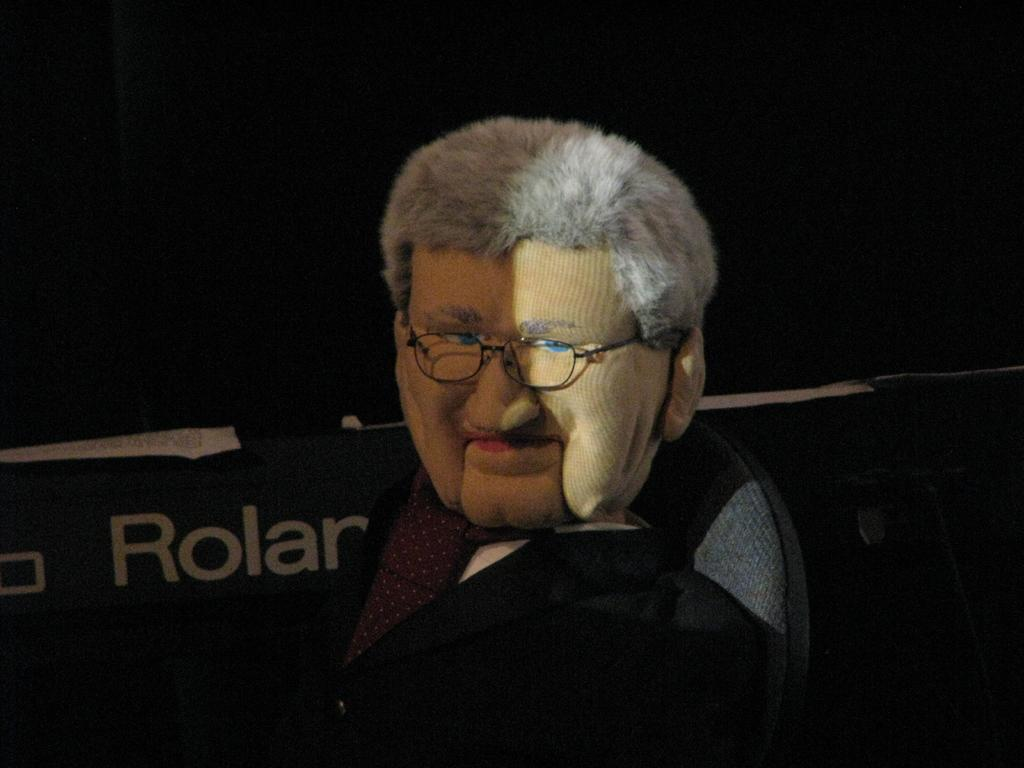What is the person in the image wearing on their face? The person in the image is wearing a mask. What is the person's posture in the image? The person is sitting on a chair. What can be seen in the background of the image? There is a hoarding in the background of the image. How would you describe the color of the background in the image? The background of the image is dark in color. What type of line can be seen connecting the person to the mine in the image? There is no mine or line connecting the person to a mine in the image. How many mittens is the person wearing in the image? The person is not wearing any mittens in the image. 